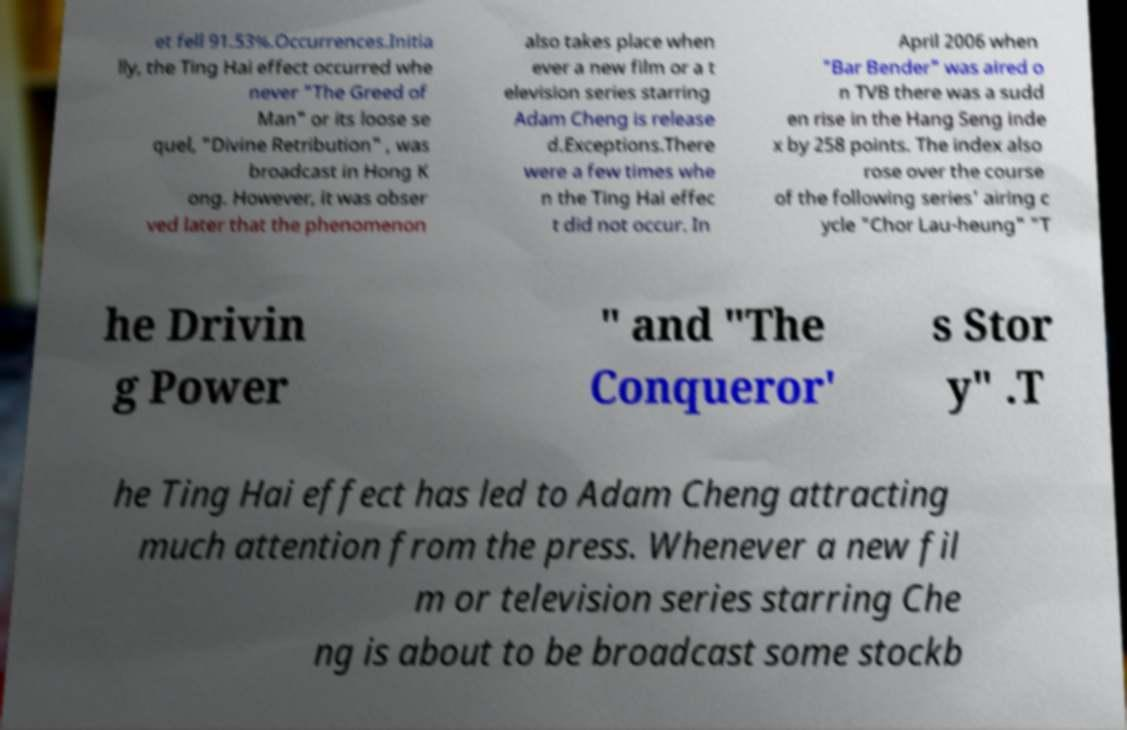Could you assist in decoding the text presented in this image and type it out clearly? et fell 91.53%.Occurrences.Initia lly, the Ting Hai effect occurred whe never "The Greed of Man" or its loose se quel, "Divine Retribution" , was broadcast in Hong K ong. However, it was obser ved later that the phenomenon also takes place when ever a new film or a t elevision series starring Adam Cheng is release d.Exceptions.There were a few times whe n the Ting Hai effec t did not occur. In April 2006 when "Bar Bender" was aired o n TVB there was a sudd en rise in the Hang Seng inde x by 258 points. The index also rose over the course of the following series' airing c ycle "Chor Lau-heung" "T he Drivin g Power " and "The Conqueror' s Stor y" .T he Ting Hai effect has led to Adam Cheng attracting much attention from the press. Whenever a new fil m or television series starring Che ng is about to be broadcast some stockb 